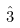Convert formula to latex. <formula><loc_0><loc_0><loc_500><loc_500>\hat { 3 }</formula> 